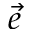<formula> <loc_0><loc_0><loc_500><loc_500>\ V e c { e }</formula> 